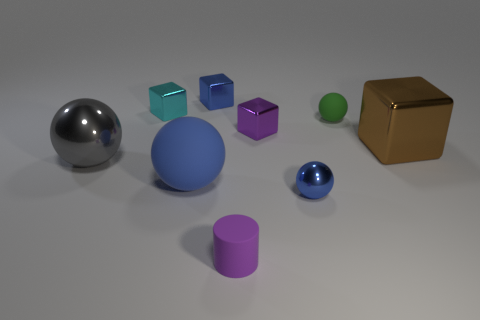Subtract all tiny blocks. How many blocks are left? 1 Add 1 purple cylinders. How many objects exist? 10 Subtract all blue blocks. How many blocks are left? 3 Subtract 1 spheres. How many spheres are left? 3 Add 2 balls. How many balls are left? 6 Add 1 small blue blocks. How many small blue blocks exist? 2 Subtract 1 purple cylinders. How many objects are left? 8 Subtract all blocks. How many objects are left? 5 Subtract all brown spheres. Subtract all cyan cylinders. How many spheres are left? 4 Subtract all purple cylinders. How many blue balls are left? 2 